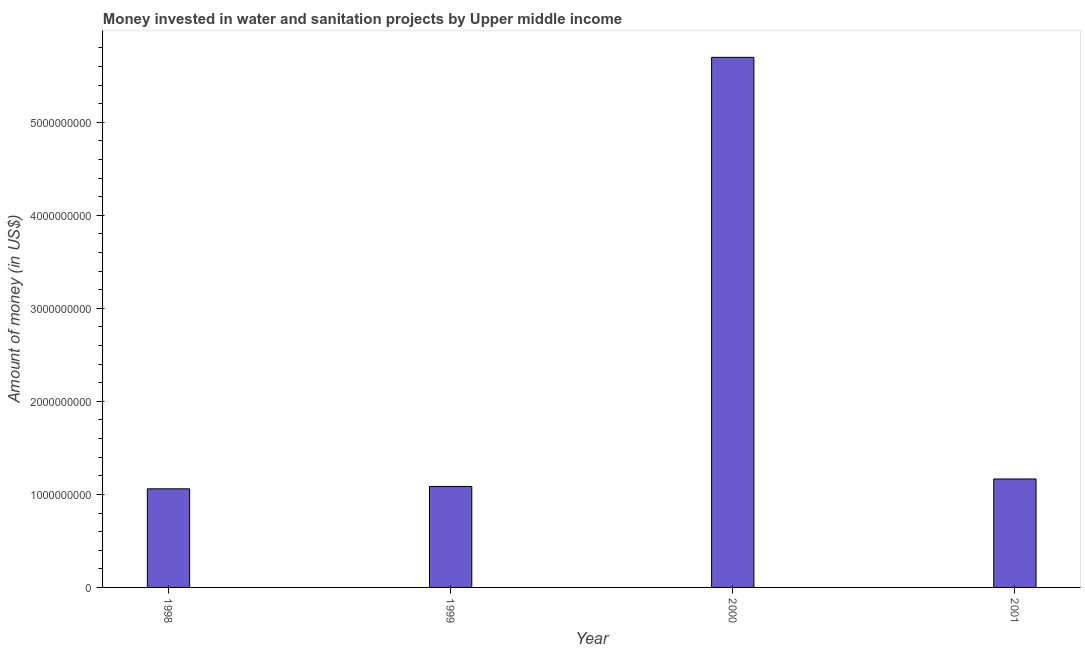Does the graph contain grids?
Offer a very short reply. No. What is the title of the graph?
Make the answer very short. Money invested in water and sanitation projects by Upper middle income. What is the label or title of the Y-axis?
Your answer should be compact. Amount of money (in US$). What is the investment in 1999?
Provide a short and direct response. 1.09e+09. Across all years, what is the maximum investment?
Keep it short and to the point. 5.70e+09. Across all years, what is the minimum investment?
Make the answer very short. 1.06e+09. What is the sum of the investment?
Offer a terse response. 9.01e+09. What is the difference between the investment in 1998 and 2001?
Ensure brevity in your answer.  -1.06e+08. What is the average investment per year?
Offer a very short reply. 2.25e+09. What is the median investment?
Give a very brief answer. 1.13e+09. Do a majority of the years between 1998 and 2001 (inclusive) have investment greater than 2600000000 US$?
Offer a terse response. No. What is the ratio of the investment in 1999 to that in 2000?
Your response must be concise. 0.19. What is the difference between the highest and the second highest investment?
Your response must be concise. 4.53e+09. What is the difference between the highest and the lowest investment?
Your answer should be very brief. 4.64e+09. Are all the bars in the graph horizontal?
Your response must be concise. No. How many years are there in the graph?
Keep it short and to the point. 4. What is the Amount of money (in US$) of 1998?
Keep it short and to the point. 1.06e+09. What is the Amount of money (in US$) in 1999?
Offer a very short reply. 1.09e+09. What is the Amount of money (in US$) in 2000?
Offer a very short reply. 5.70e+09. What is the Amount of money (in US$) in 2001?
Keep it short and to the point. 1.17e+09. What is the difference between the Amount of money (in US$) in 1998 and 1999?
Provide a short and direct response. -2.56e+07. What is the difference between the Amount of money (in US$) in 1998 and 2000?
Offer a terse response. -4.64e+09. What is the difference between the Amount of money (in US$) in 1998 and 2001?
Ensure brevity in your answer.  -1.06e+08. What is the difference between the Amount of money (in US$) in 1999 and 2000?
Ensure brevity in your answer.  -4.61e+09. What is the difference between the Amount of money (in US$) in 1999 and 2001?
Offer a terse response. -8.01e+07. What is the difference between the Amount of money (in US$) in 2000 and 2001?
Keep it short and to the point. 4.53e+09. What is the ratio of the Amount of money (in US$) in 1998 to that in 1999?
Your response must be concise. 0.98. What is the ratio of the Amount of money (in US$) in 1998 to that in 2000?
Offer a very short reply. 0.19. What is the ratio of the Amount of money (in US$) in 1998 to that in 2001?
Give a very brief answer. 0.91. What is the ratio of the Amount of money (in US$) in 1999 to that in 2000?
Keep it short and to the point. 0.19. What is the ratio of the Amount of money (in US$) in 2000 to that in 2001?
Offer a very short reply. 4.89. 